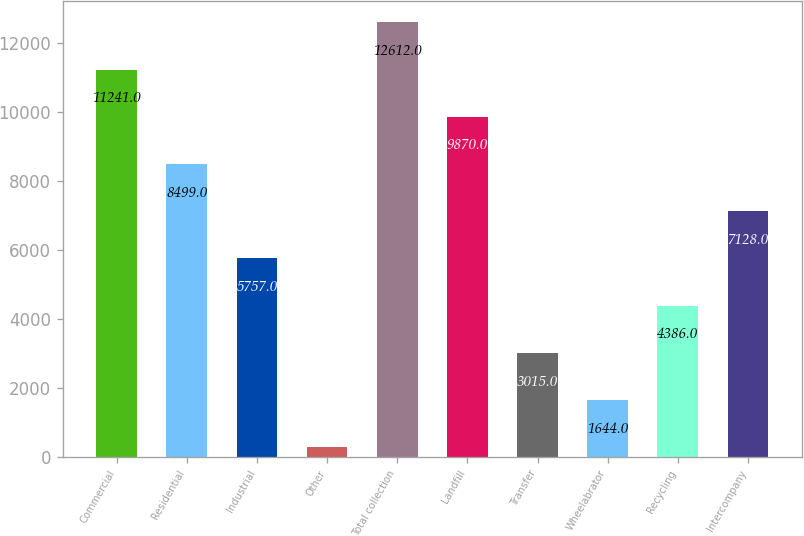Convert chart. <chart><loc_0><loc_0><loc_500><loc_500><bar_chart><fcel>Commercial<fcel>Residential<fcel>Industrial<fcel>Other<fcel>Total collection<fcel>Landfill<fcel>Transfer<fcel>Wheelabrator<fcel>Recycling<fcel>Intercompany<nl><fcel>11241<fcel>8499<fcel>5757<fcel>273<fcel>12612<fcel>9870<fcel>3015<fcel>1644<fcel>4386<fcel>7128<nl></chart> 